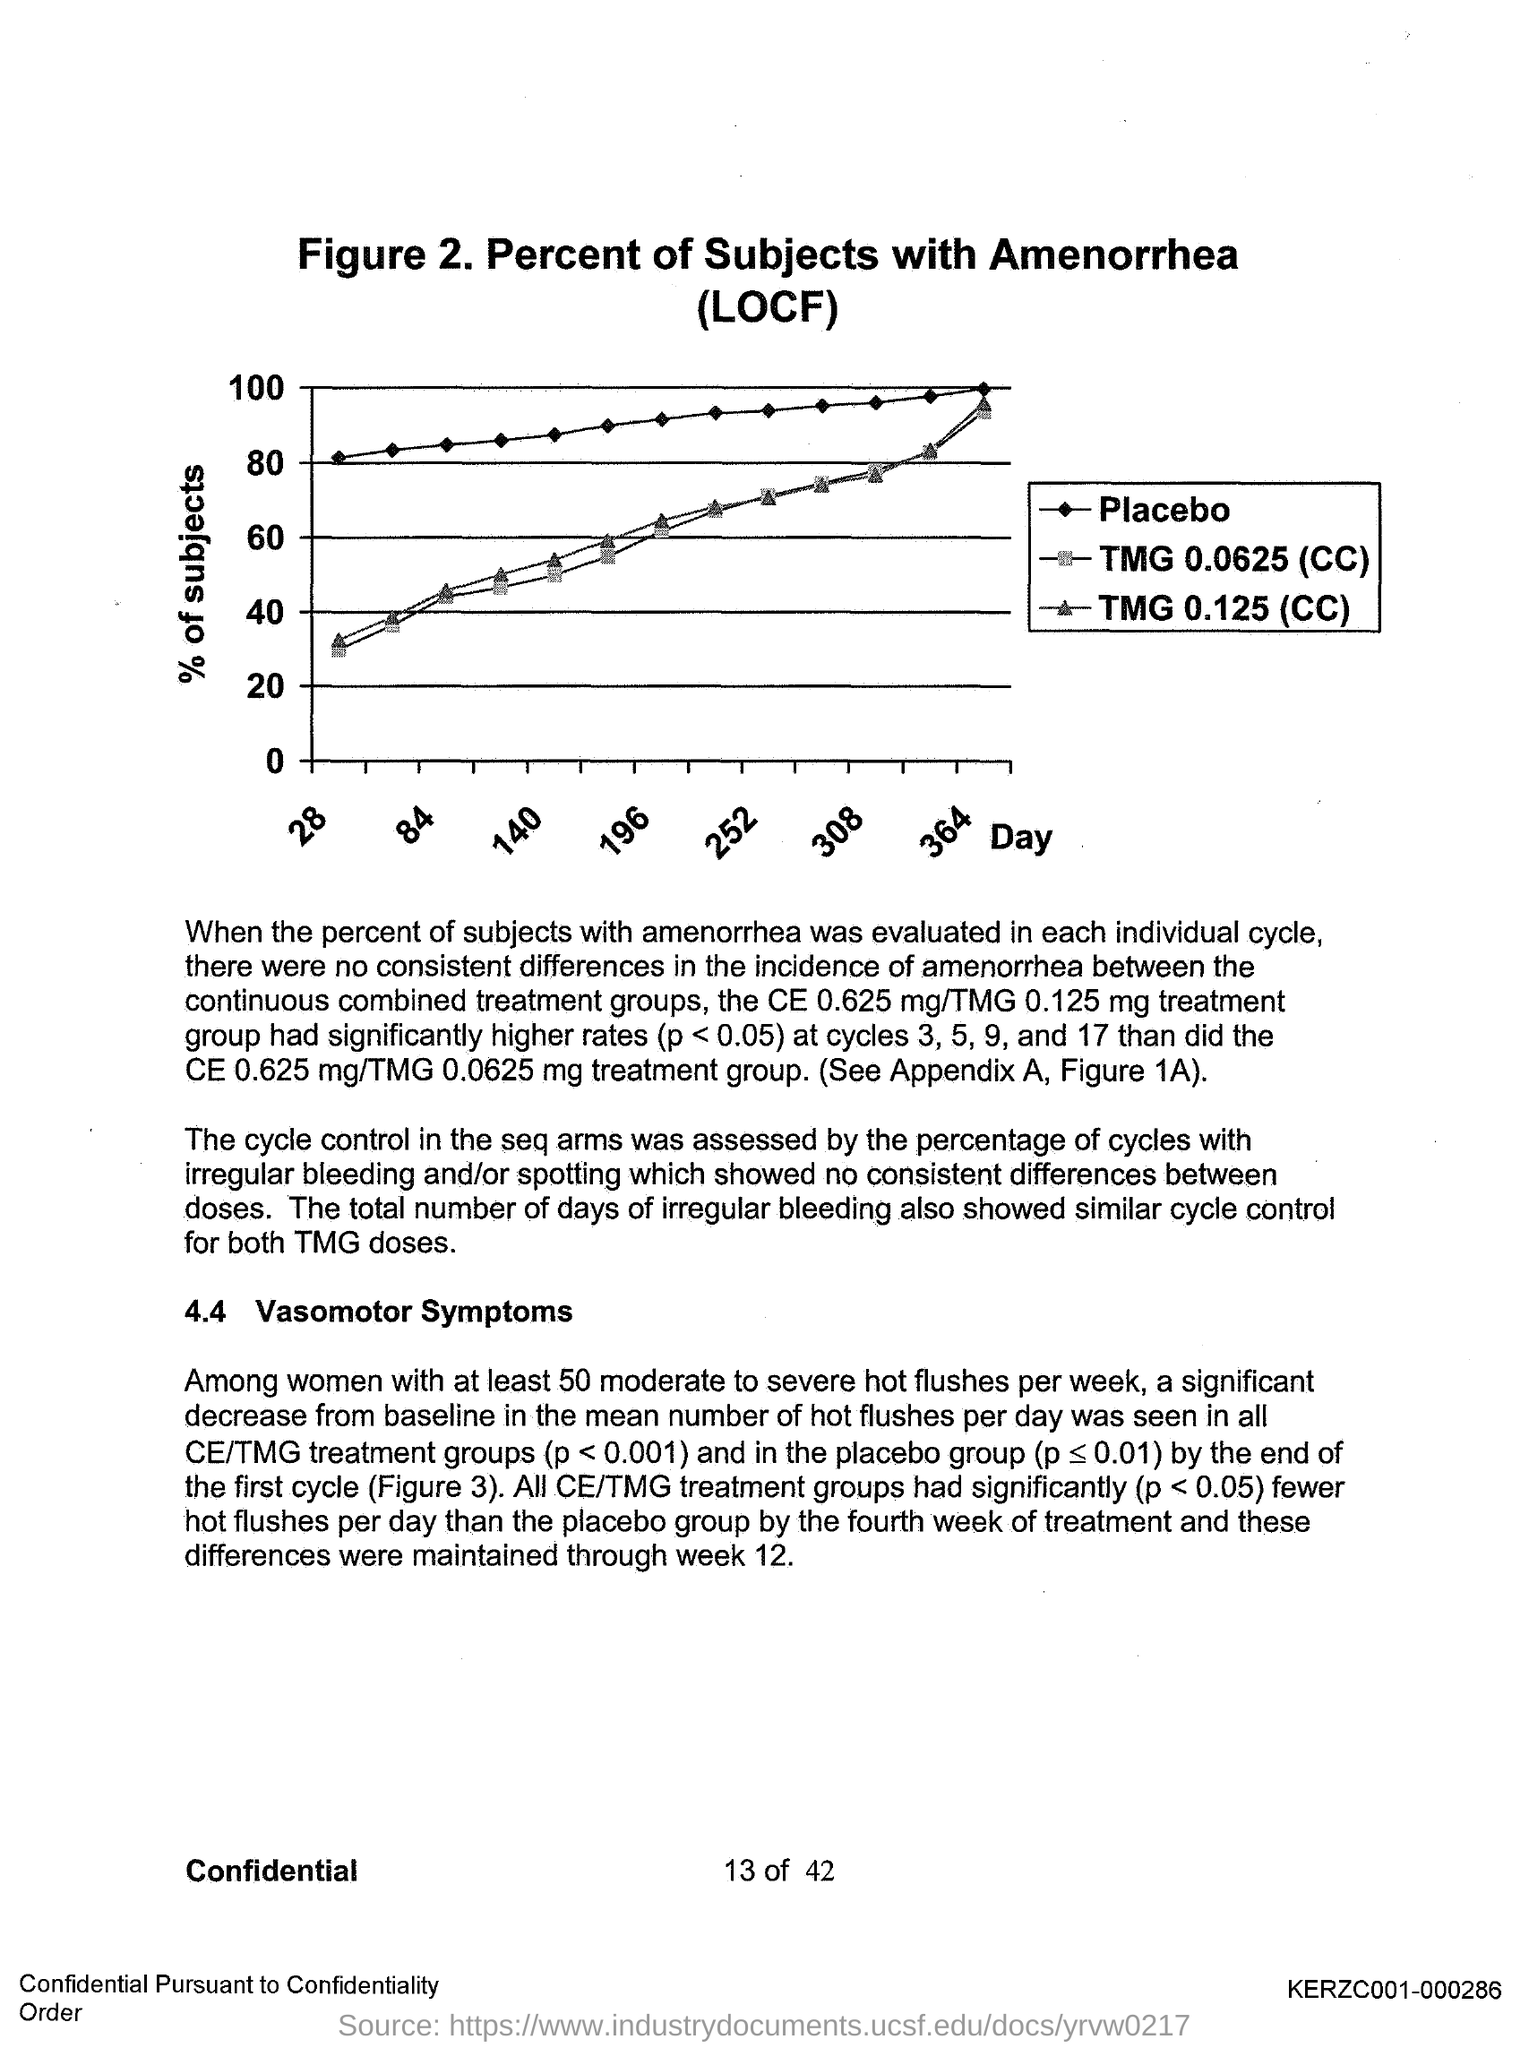What is the figure number?
Offer a very short reply. 2. What is plotted on the x-axis?
Your answer should be compact. Day. What is plotted on the y-axis?
Provide a short and direct response. % of subjects. 